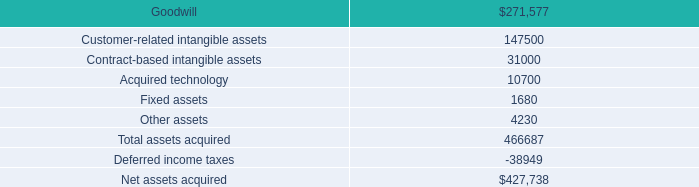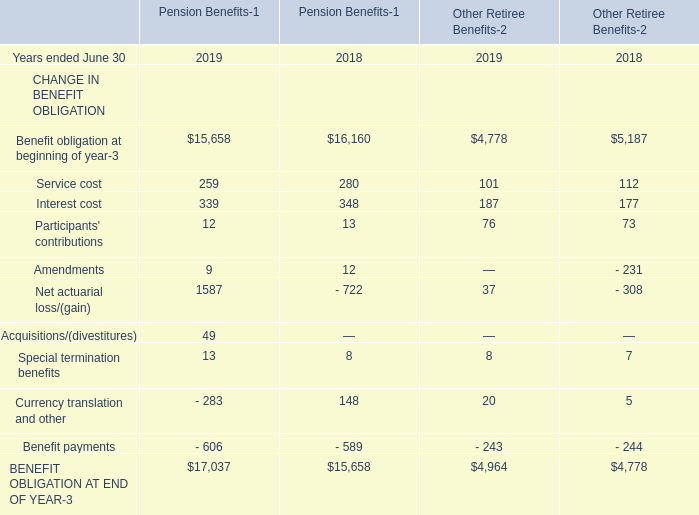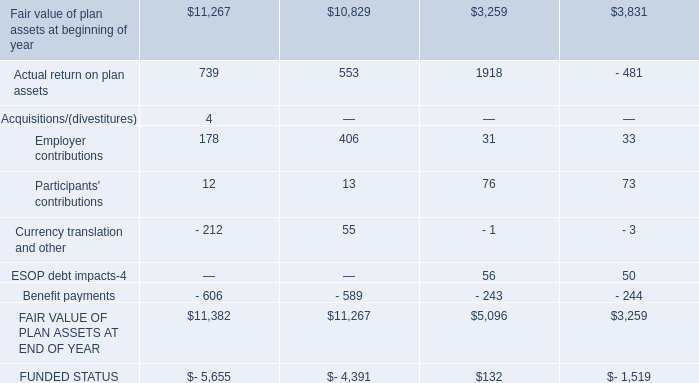what percent of assets for the acquisition of paypros was deductible for taxes? 
Computations: ((147500 + (10700 + 31000)) / 466687)
Answer: 0.40541. 